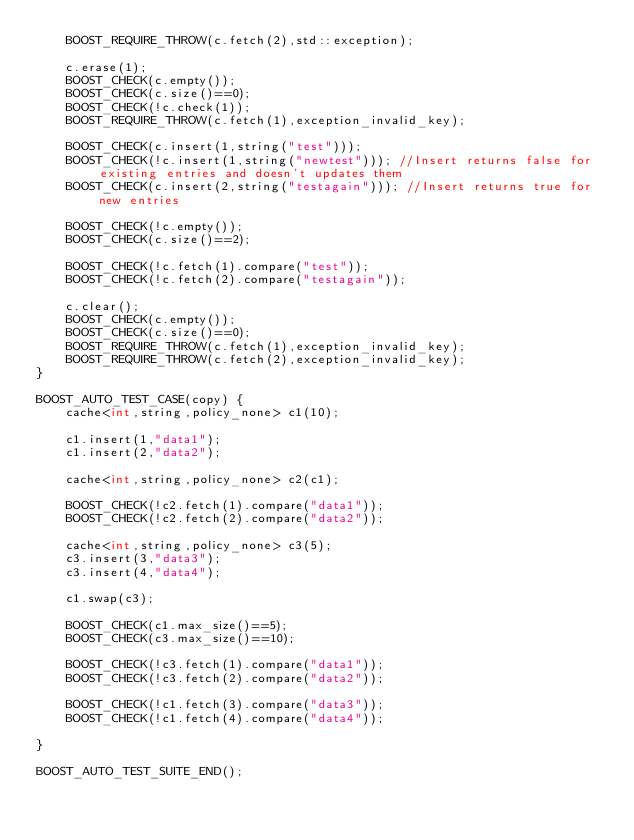Convert code to text. <code><loc_0><loc_0><loc_500><loc_500><_C++_>    BOOST_REQUIRE_THROW(c.fetch(2),std::exception);

    c.erase(1);
    BOOST_CHECK(c.empty());
    BOOST_CHECK(c.size()==0);
    BOOST_CHECK(!c.check(1));
    BOOST_REQUIRE_THROW(c.fetch(1),exception_invalid_key);

    BOOST_CHECK(c.insert(1,string("test")));
    BOOST_CHECK(!c.insert(1,string("newtest"))); //Insert returns false for existing entries and doesn't updates them
    BOOST_CHECK(c.insert(2,string("testagain"))); //Insert returns true for new entries

    BOOST_CHECK(!c.empty());
    BOOST_CHECK(c.size()==2);

    BOOST_CHECK(!c.fetch(1).compare("test"));
    BOOST_CHECK(!c.fetch(2).compare("testagain"));

    c.clear();
    BOOST_CHECK(c.empty());
    BOOST_CHECK(c.size()==0);
    BOOST_REQUIRE_THROW(c.fetch(1),exception_invalid_key);
    BOOST_REQUIRE_THROW(c.fetch(2),exception_invalid_key);
}

BOOST_AUTO_TEST_CASE(copy) {
    cache<int,string,policy_none> c1(10);

    c1.insert(1,"data1");
    c1.insert(2,"data2");

    cache<int,string,policy_none> c2(c1);

    BOOST_CHECK(!c2.fetch(1).compare("data1"));
    BOOST_CHECK(!c2.fetch(2).compare("data2"));

    cache<int,string,policy_none> c3(5);
    c3.insert(3,"data3");
    c3.insert(4,"data4");

    c1.swap(c3);

    BOOST_CHECK(c1.max_size()==5);
    BOOST_CHECK(c3.max_size()==10);

    BOOST_CHECK(!c3.fetch(1).compare("data1"));
    BOOST_CHECK(!c3.fetch(2).compare("data2"));

    BOOST_CHECK(!c1.fetch(3).compare("data3"));
    BOOST_CHECK(!c1.fetch(4).compare("data4"));

}

BOOST_AUTO_TEST_SUITE_END();
</code> 